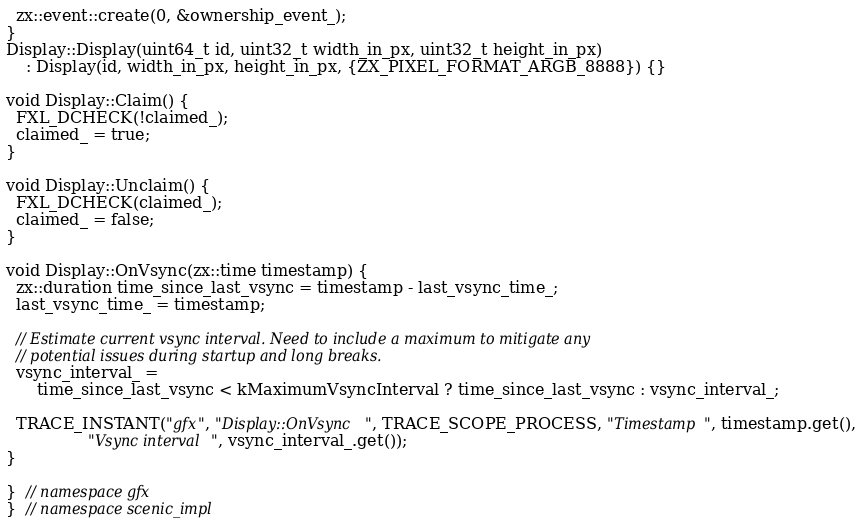<code> <loc_0><loc_0><loc_500><loc_500><_C++_>  zx::event::create(0, &ownership_event_);
}
Display::Display(uint64_t id, uint32_t width_in_px, uint32_t height_in_px)
    : Display(id, width_in_px, height_in_px, {ZX_PIXEL_FORMAT_ARGB_8888}) {}

void Display::Claim() {
  FXL_DCHECK(!claimed_);
  claimed_ = true;
}

void Display::Unclaim() {
  FXL_DCHECK(claimed_);
  claimed_ = false;
}

void Display::OnVsync(zx::time timestamp) {
  zx::duration time_since_last_vsync = timestamp - last_vsync_time_;
  last_vsync_time_ = timestamp;

  // Estimate current vsync interval. Need to include a maximum to mitigate any
  // potential issues during startup and long breaks.
  vsync_interval_ =
      time_since_last_vsync < kMaximumVsyncInterval ? time_since_last_vsync : vsync_interval_;

  TRACE_INSTANT("gfx", "Display::OnVsync", TRACE_SCOPE_PROCESS, "Timestamp", timestamp.get(),
                "Vsync interval", vsync_interval_.get());
}

}  // namespace gfx
}  // namespace scenic_impl
</code> 